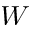<formula> <loc_0><loc_0><loc_500><loc_500>W</formula> 